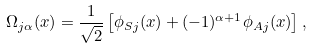<formula> <loc_0><loc_0><loc_500><loc_500>\Omega _ { j \alpha } ( x ) = \frac { 1 } { \sqrt { 2 } } \left [ \phi _ { S j } ( x ) + ( - 1 ) ^ { \alpha + 1 } \phi _ { A j } ( x ) \right ] ,</formula> 